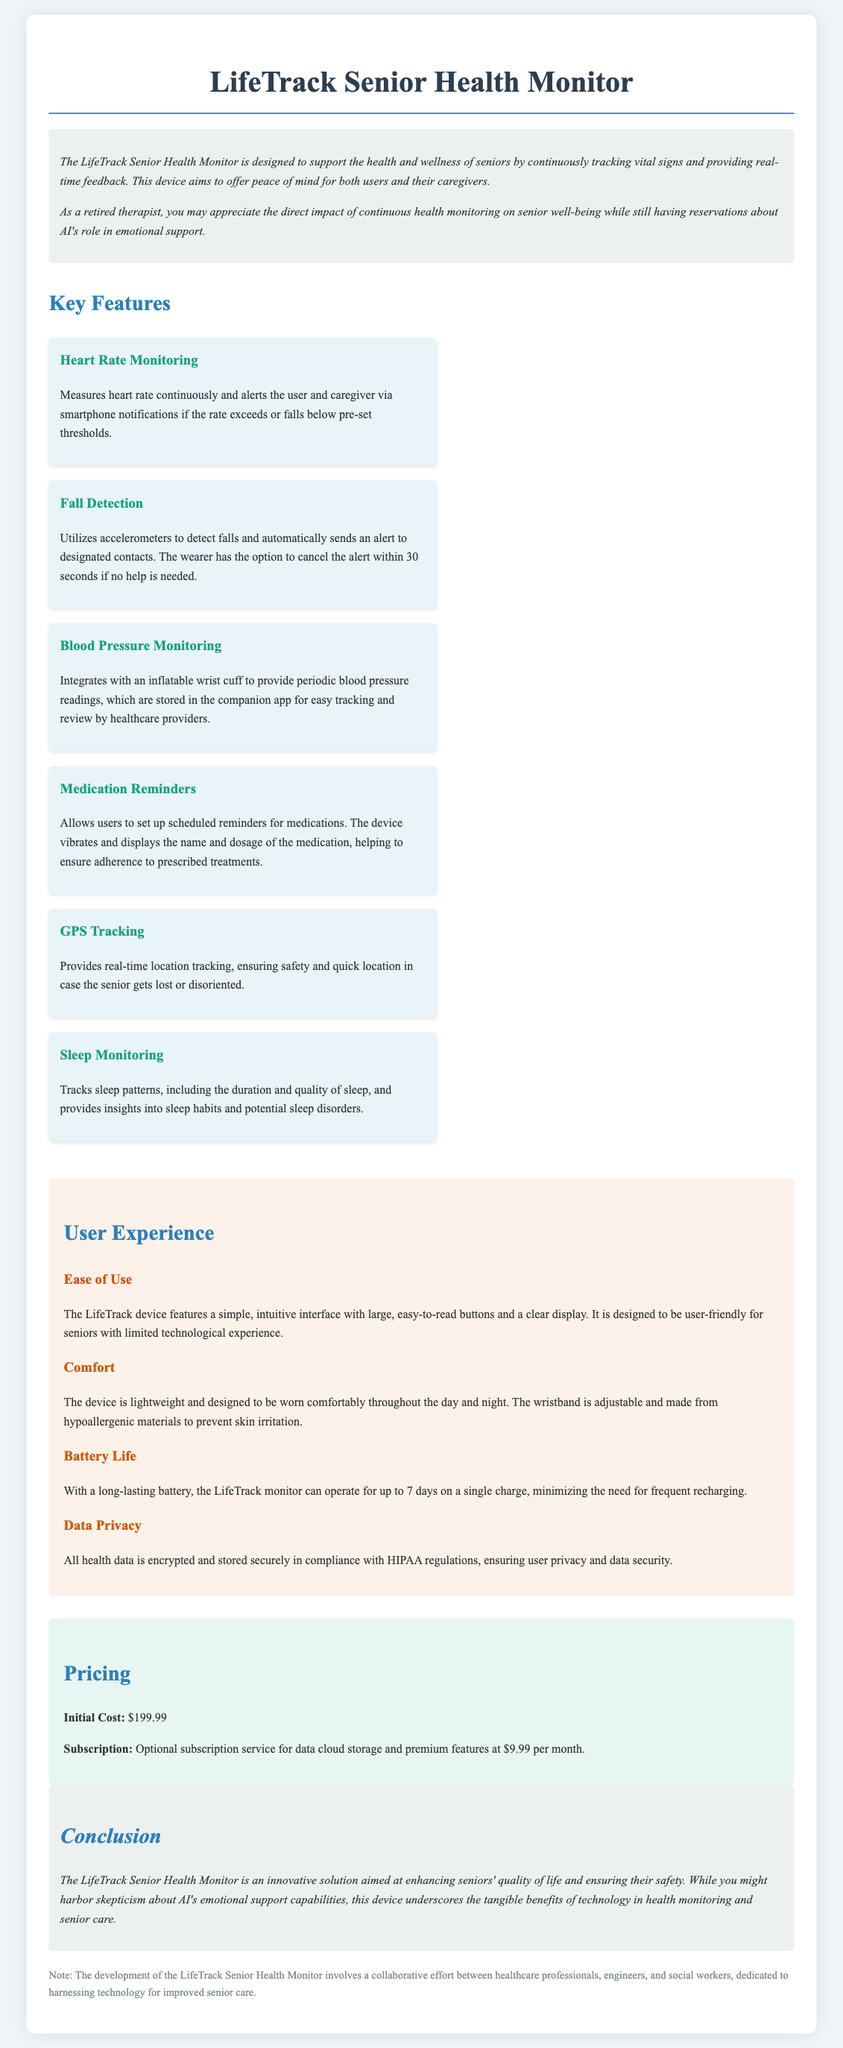What is the initial cost of the device? The initial cost is stated clearly in the pricing section of the document.
Answer: $199.99 How long can the device operate on a single charge? The battery life information is provided in the user experience section of the document.
Answer: 7 days What feature provides peace of mind in case of falls? The document describes the fall detection feature in the features section.
Answer: Fall Detection What purpose does the GPS tracking feature serve? The purpose of GPS tracking is mentioned in the features section.
Answer: Ensuring safety What is the optional subscription cost per month? The subscription cost information is located in the pricing section of the document.
Answer: $9.99 How is user data protected according to the document? The document discusses data privacy measures in the user experience section.
Answer: Encrypted and stored securely What materials is the wristband made of? The material information is provided in the comfort section of the user experience.
Answer: Hypoallergenic materials What type of data does the blood pressure monitor integrate with? The blood pressure monitoring device integration is explained in the features.
Answer: Inflatable wrist cuff 